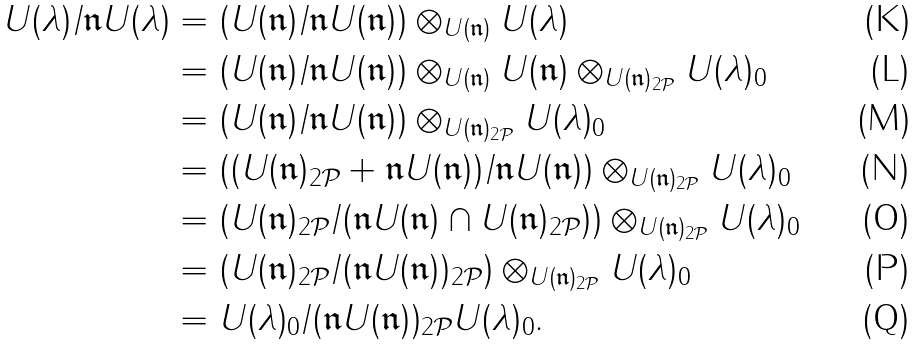<formula> <loc_0><loc_0><loc_500><loc_500>U ( \lambda ) / \mathfrak { n } U ( \lambda ) & = ( U ( \mathfrak { n } ) / \mathfrak { n } U ( \mathfrak { n } ) ) \otimes _ { U ( \mathfrak { n } ) } U ( \lambda ) \\ & = ( U ( \mathfrak { n } ) / \mathfrak { n } U ( \mathfrak { n } ) ) \otimes _ { U ( \mathfrak { n } ) } U ( \mathfrak { n } ) \otimes _ { U ( \mathfrak { n } ) _ { 2 \mathcal { P } } } U ( \lambda ) _ { 0 } \\ & = ( U ( \mathfrak { n } ) / \mathfrak { n } U ( \mathfrak { n } ) ) \otimes _ { U ( \mathfrak { n } ) _ { 2 \mathcal { P } } } U ( \lambda ) _ { 0 } \\ & = ( ( U ( \mathfrak { n } ) _ { 2 \mathcal { P } } + \mathfrak { n } U ( \mathfrak { n } ) ) / \mathfrak { n } U ( \mathfrak { n } ) ) \otimes _ { U ( \mathfrak { n } ) _ { 2 \mathcal { P } } } U ( \lambda ) _ { 0 } \\ & = ( U ( \mathfrak { n } ) _ { 2 \mathcal { P } } / ( \mathfrak { n } U ( \mathfrak { n } ) \cap U ( \mathfrak { n } ) _ { 2 \mathcal { P } } ) ) \otimes _ { U ( \mathfrak { n } ) _ { 2 \mathcal { P } } } U ( \lambda ) _ { 0 } \\ & = ( U ( \mathfrak { n } ) _ { 2 \mathcal { P } } / ( \mathfrak { n } U ( \mathfrak { n } ) ) _ { 2 \mathcal { P } } ) \otimes _ { U ( \mathfrak { n } ) _ { 2 \mathcal { P } } } U ( \lambda ) _ { 0 } \\ & = U ( \lambda ) _ { 0 } / ( \mathfrak { n } U ( \mathfrak { n } ) ) _ { 2 \mathcal { P } } U ( \lambda ) _ { 0 } .</formula> 